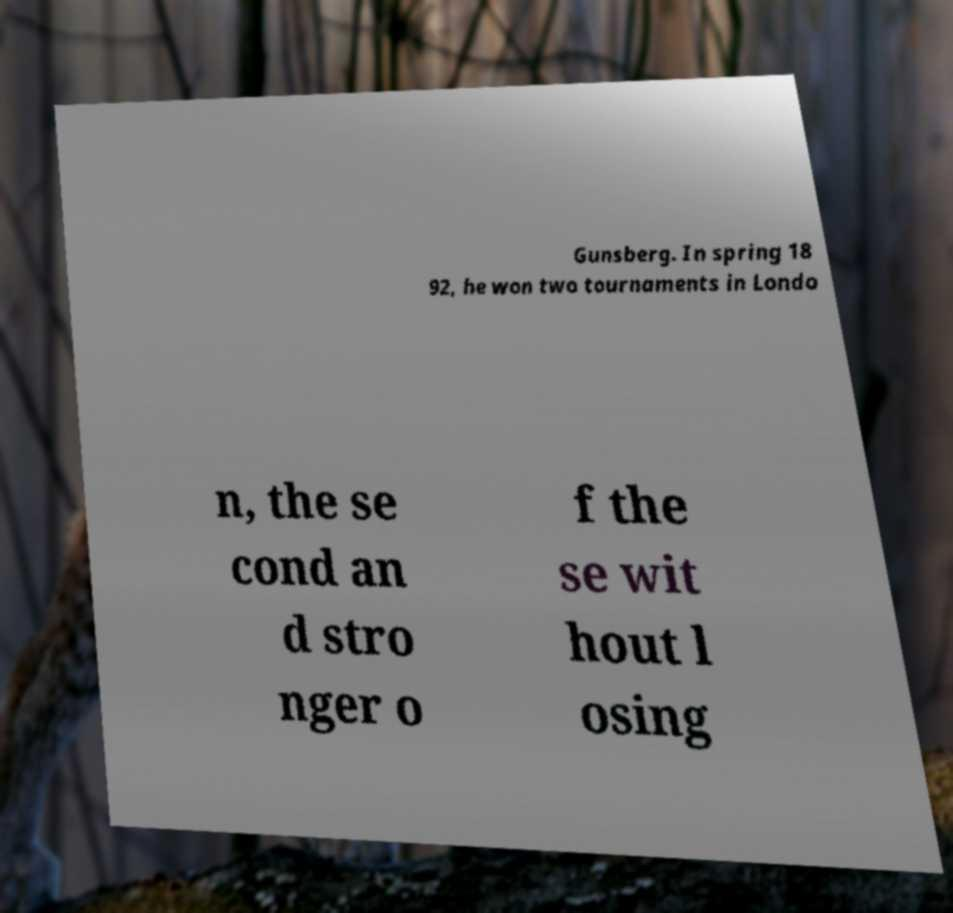I need the written content from this picture converted into text. Can you do that? Gunsberg. In spring 18 92, he won two tournaments in Londo n, the se cond an d stro nger o f the se wit hout l osing 